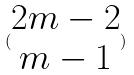Convert formula to latex. <formula><loc_0><loc_0><loc_500><loc_500>( \begin{matrix} 2 m - 2 \\ m - 1 \end{matrix} )</formula> 